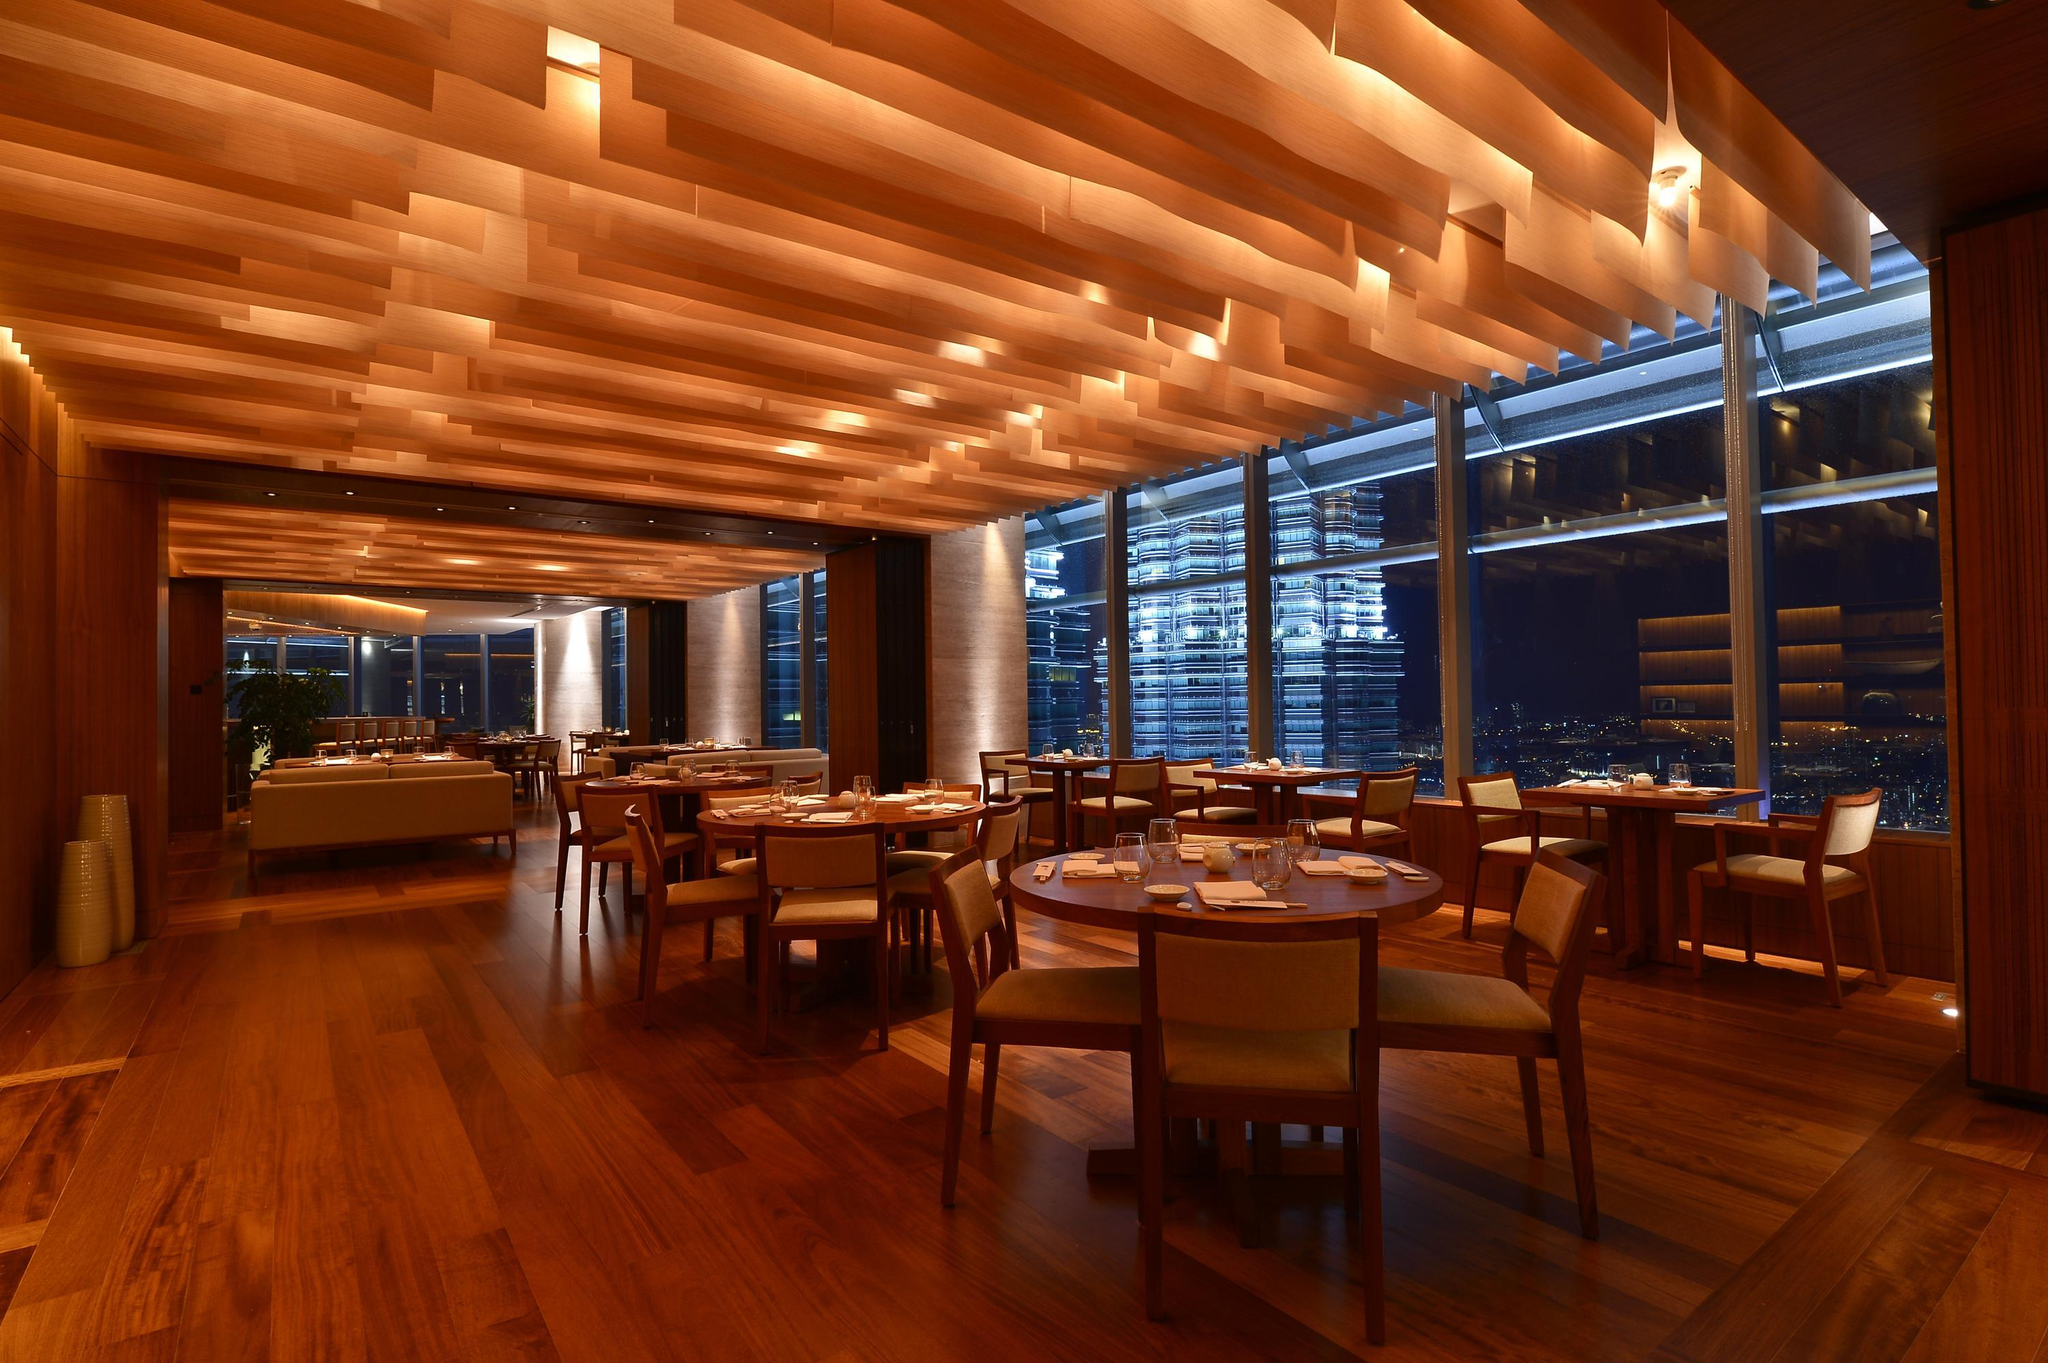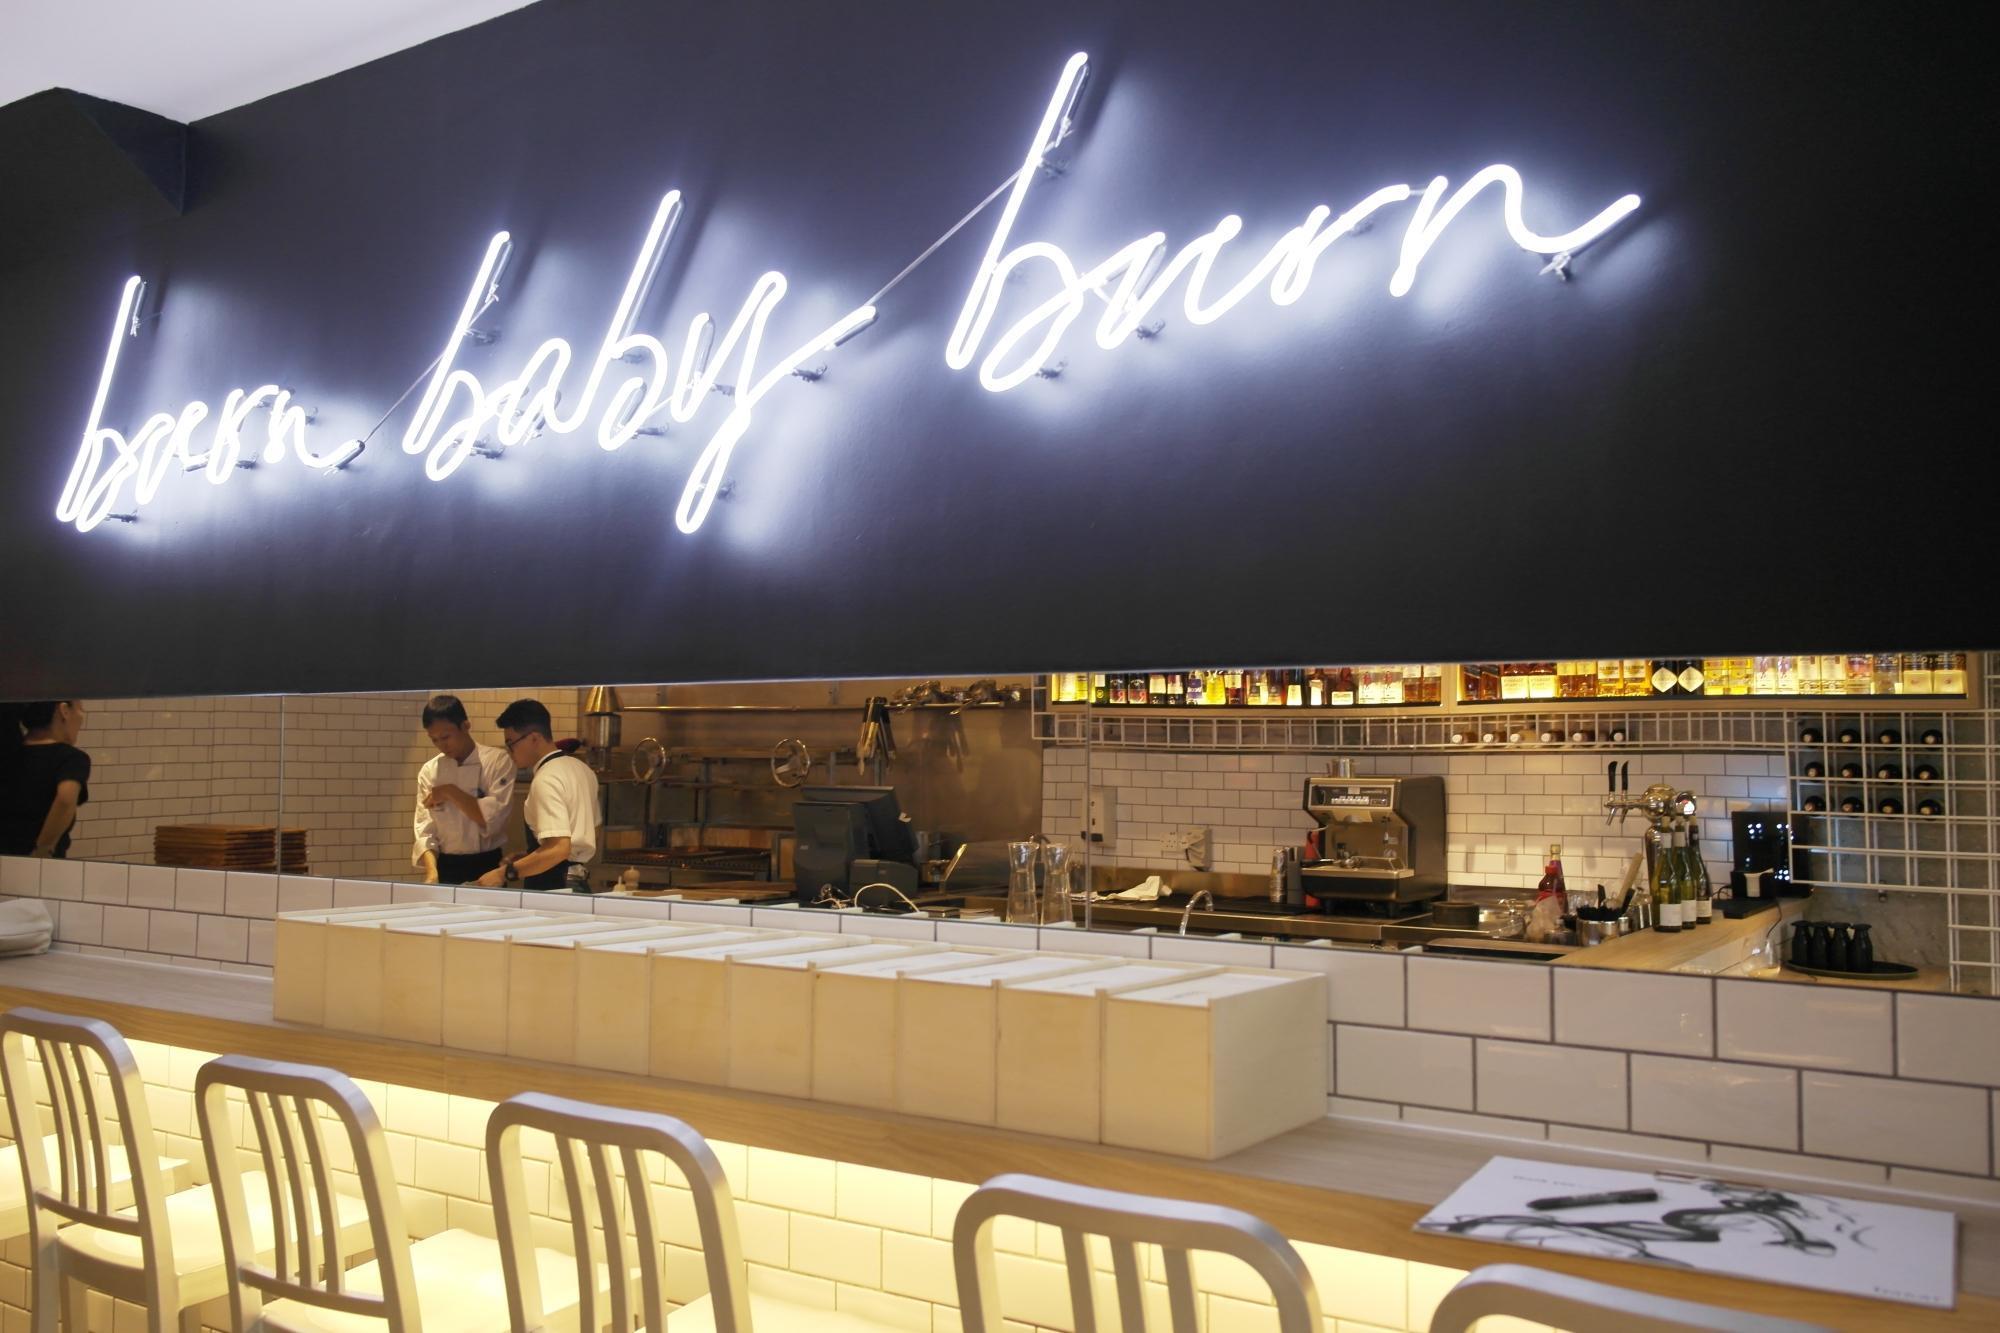The first image is the image on the left, the second image is the image on the right. Considering the images on both sides, is "At least one photo shows a dining area that is completely lit and also void of guests." valid? Answer yes or no. Yes. The first image is the image on the left, the second image is the image on the right. For the images displayed, is the sentence "There are at least four round tables with four armless chairs." factually correct? Answer yes or no. Yes. 